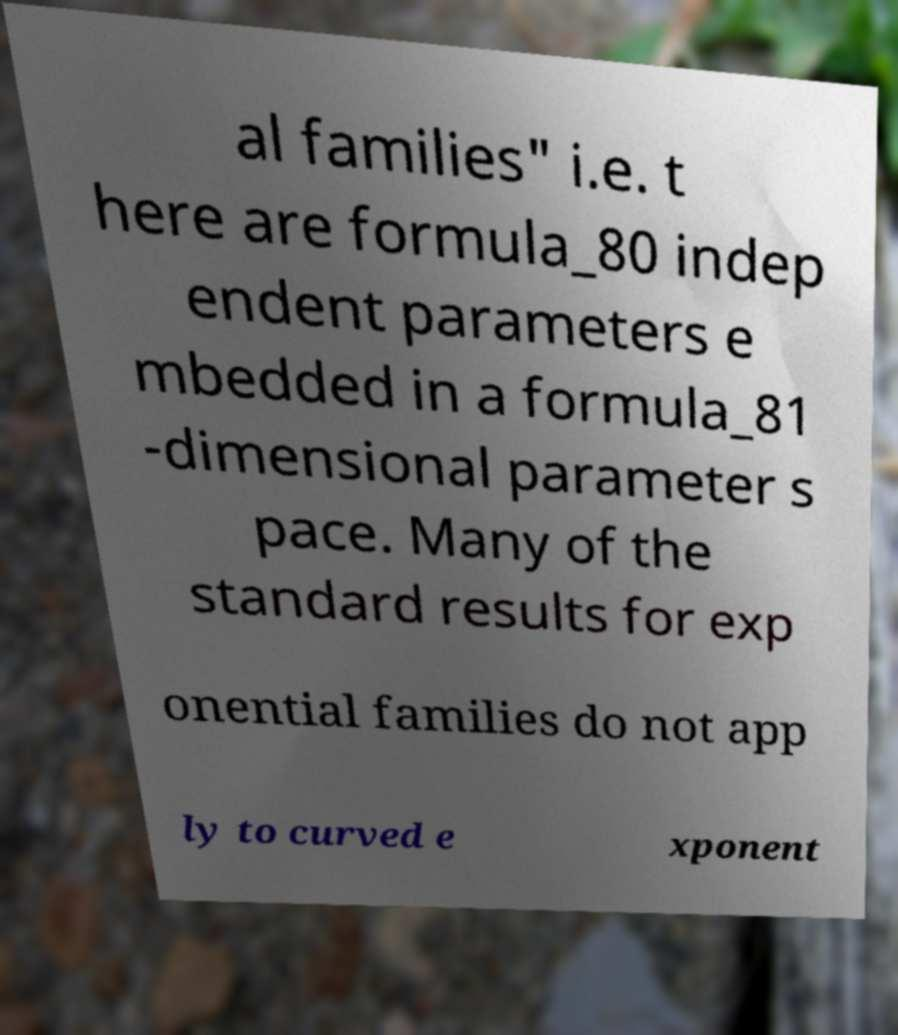Can you accurately transcribe the text from the provided image for me? al families" i.e. t here are formula_80 indep endent parameters e mbedded in a formula_81 -dimensional parameter s pace. Many of the standard results for exp onential families do not app ly to curved e xponent 